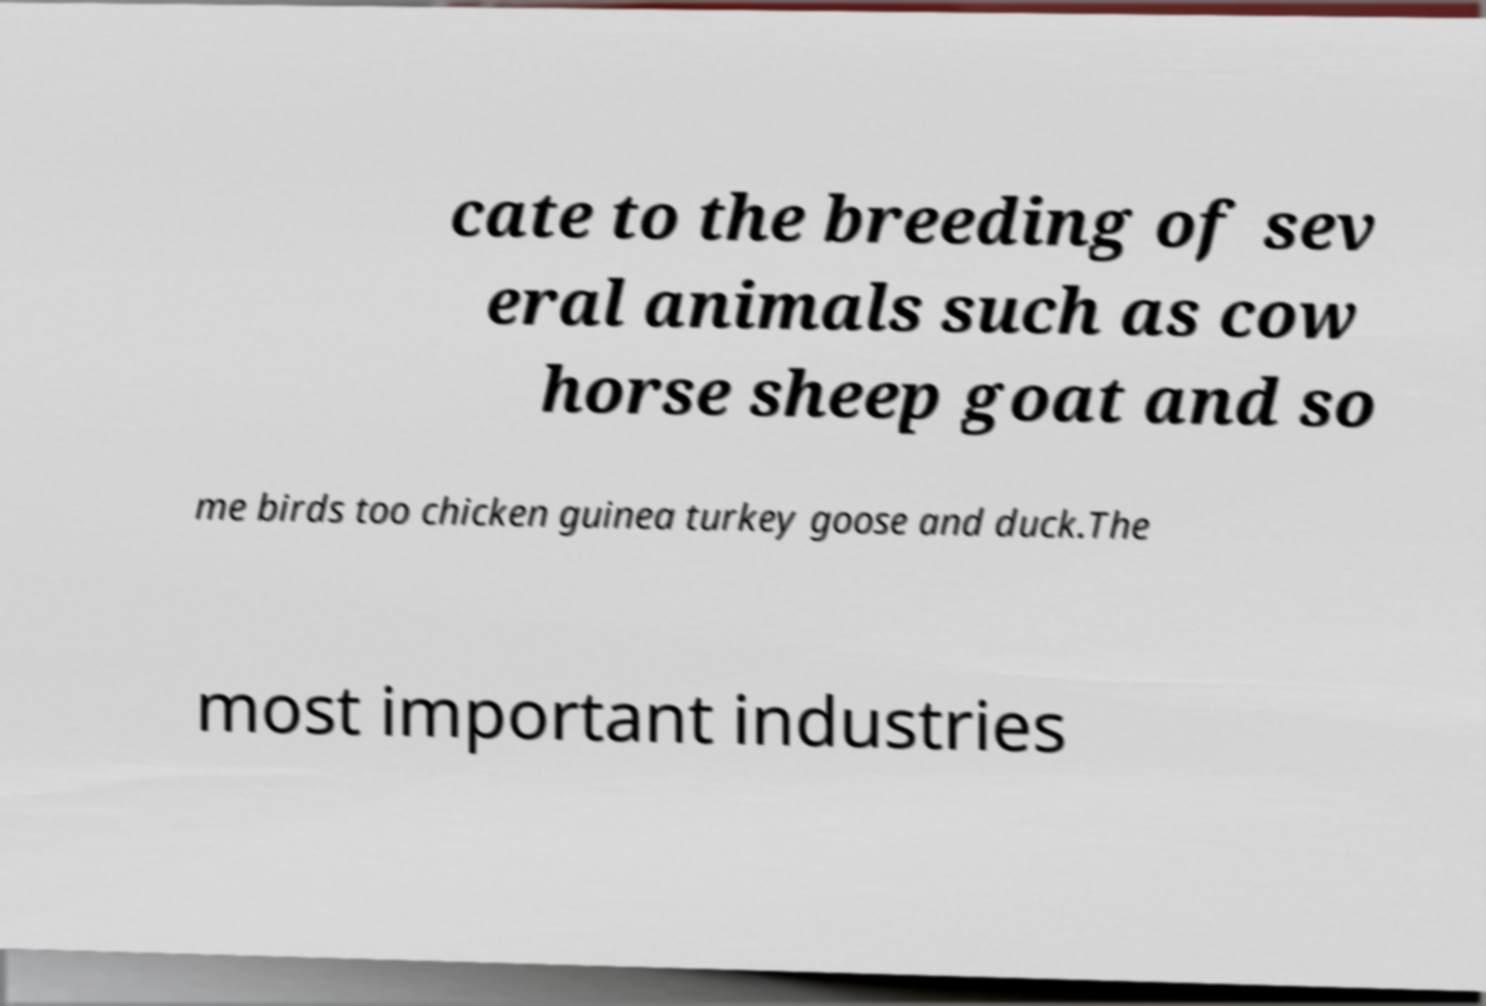Please identify and transcribe the text found in this image. cate to the breeding of sev eral animals such as cow horse sheep goat and so me birds too chicken guinea turkey goose and duck.The most important industries 